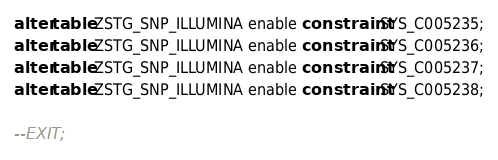Convert code to text. <code><loc_0><loc_0><loc_500><loc_500><_SQL_>alter table ZSTG_SNP_ILLUMINA enable constraint SYS_C005235;
alter table ZSTG_SNP_ILLUMINA enable constraint SYS_C005236;
alter table ZSTG_SNP_ILLUMINA enable constraint SYS_C005237;
alter table ZSTG_SNP_ILLUMINA enable constraint SYS_C005238;

--EXIT;
</code> 